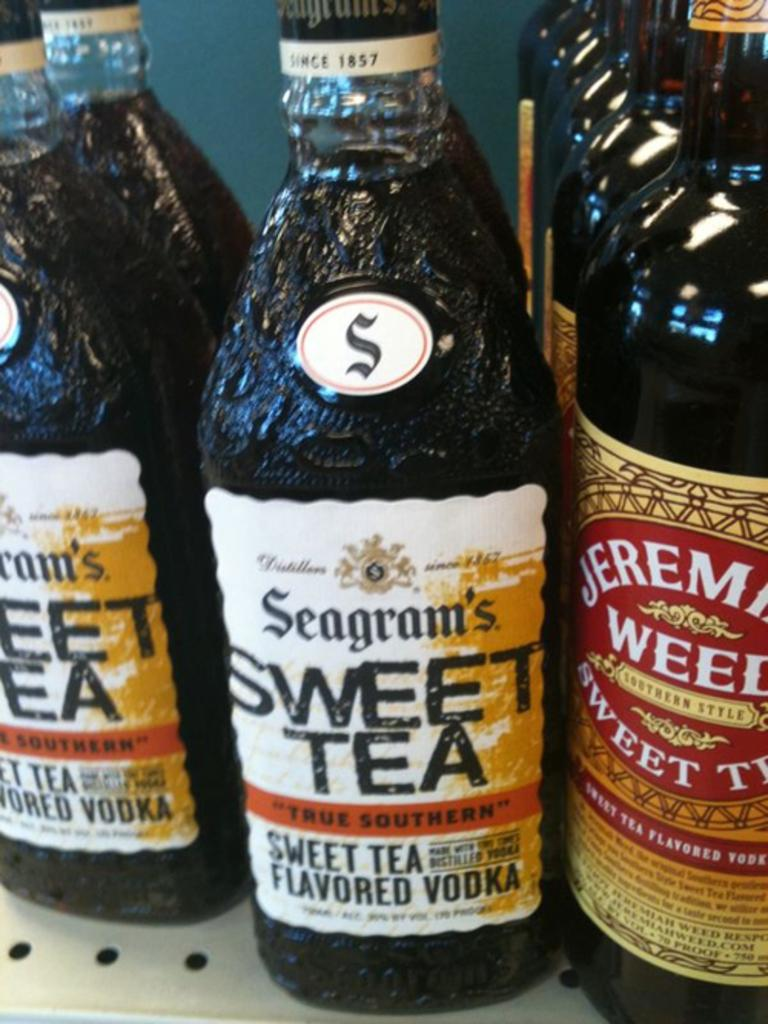Provide a one-sentence caption for the provided image. A close up of several bottles bearing the label sweet tea. 